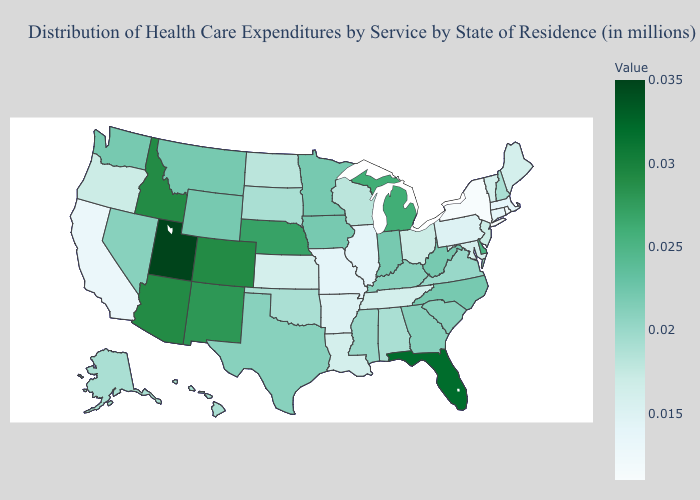Which states have the lowest value in the USA?
Keep it brief. New York. Is the legend a continuous bar?
Concise answer only. Yes. Among the states that border Idaho , which have the lowest value?
Keep it brief. Oregon. Does Utah have the highest value in the USA?
Give a very brief answer. Yes. 